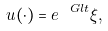<formula> <loc_0><loc_0><loc_500><loc_500>u ( \cdot ) = e ^ { \ G l t } \xi ,</formula> 